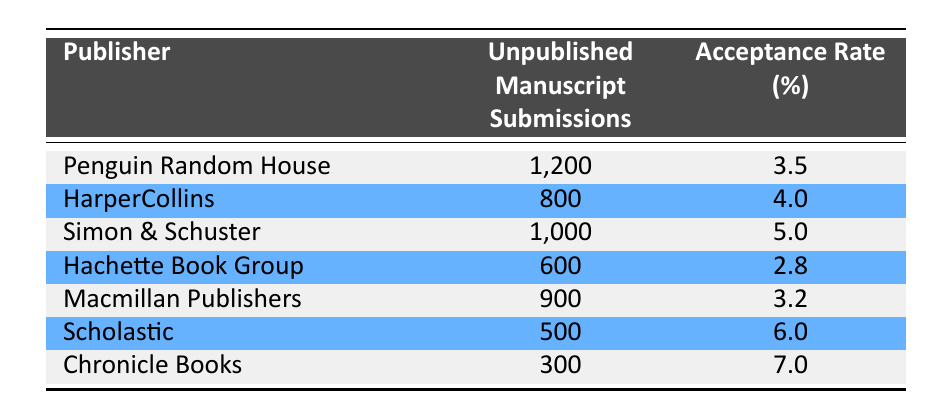What is the acceptance rate for Scholastic? The table shows that the acceptance rate for Scholastic is listed next to its submissions. It specifies that the acceptance rate percentage is 6.0.
Answer: 6.0 Which publisher had the highest number of unpublished manuscript submissions? By comparing the submissions listed in the table, Penguin Random House has the highest number of submissions at 1,200.
Answer: Penguin Random House What is the average acceptance rate for the publishers listed in the table? To find the average acceptance rate, we sum all the acceptance rates (3.5 + 4.0 + 5.0 + 2.8 + 3.2 + 6.0 + 7.0 = 31.5) and divide by the number of publishers (7). Therefore, 31.5 / 7 = 4.5.
Answer: 4.5 Is the acceptance rate for Hachette Book Group higher than that of Macmillan Publishers? The acceptance rate for Hachette Book Group is 2.8, while for Macmillan Publishers it is 3.2. Since 2.8 is less than 3.2, the statement is false.
Answer: No Which publisher has the lowest acceptance rate, and what is it? By examining the acceptance rates in the table, Hachette Book Group has the lowest acceptance rate at 2.8.
Answer: Hachette Book Group, 2.8 If a publisher accepts 4% of its submissions, how many unpublished manuscripts would that represent for 600 submissions? To find the number of accepted manuscripts, we calculate 4% of 600. This is done by multiplying 600 by 0.04, which gives us 24. Therefore, 600 submissions would result in 24 accepted manuscripts at a 4% acceptance rate.
Answer: 24 How many total unpublished manuscript submissions were made to the publishers in the table? We add all the unpublished manuscript submissions together (1200 + 800 + 1000 + 600 + 900 + 500 + 300 = 4300) to find the total.
Answer: 4300 Is the acceptance rate for Simon & Schuster greater than the acceptance rate for HarperCollins? The acceptance rate for Simon & Schuster is 5.0, while for HarperCollins it is 4.0. Since 5.0 is greater than 4.0, this statement is true.
Answer: Yes 